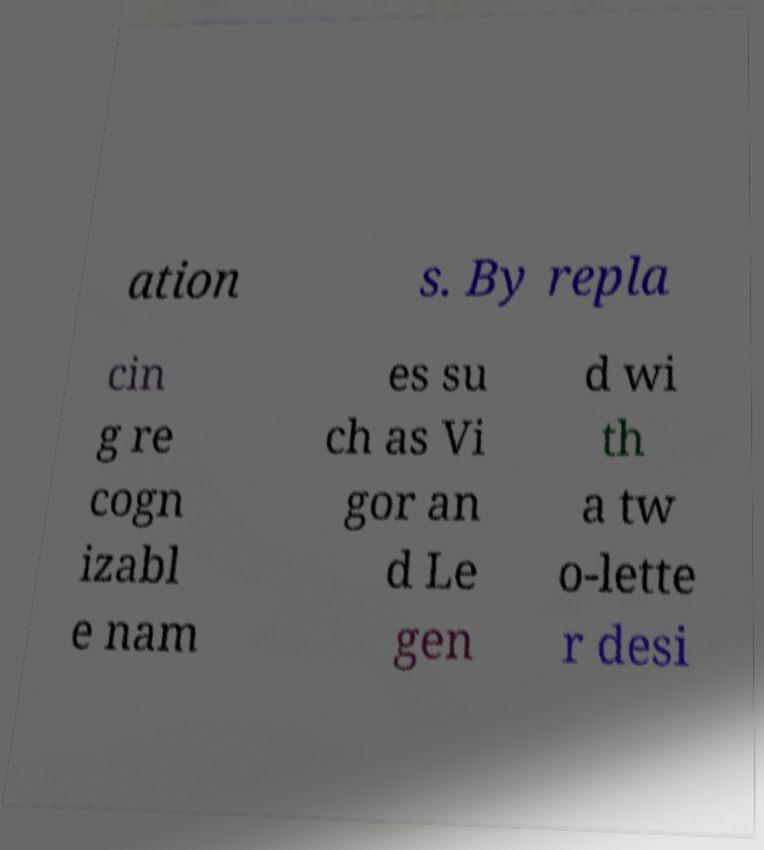Can you accurately transcribe the text from the provided image for me? ation s. By repla cin g re cogn izabl e nam es su ch as Vi gor an d Le gen d wi th a tw o-lette r desi 